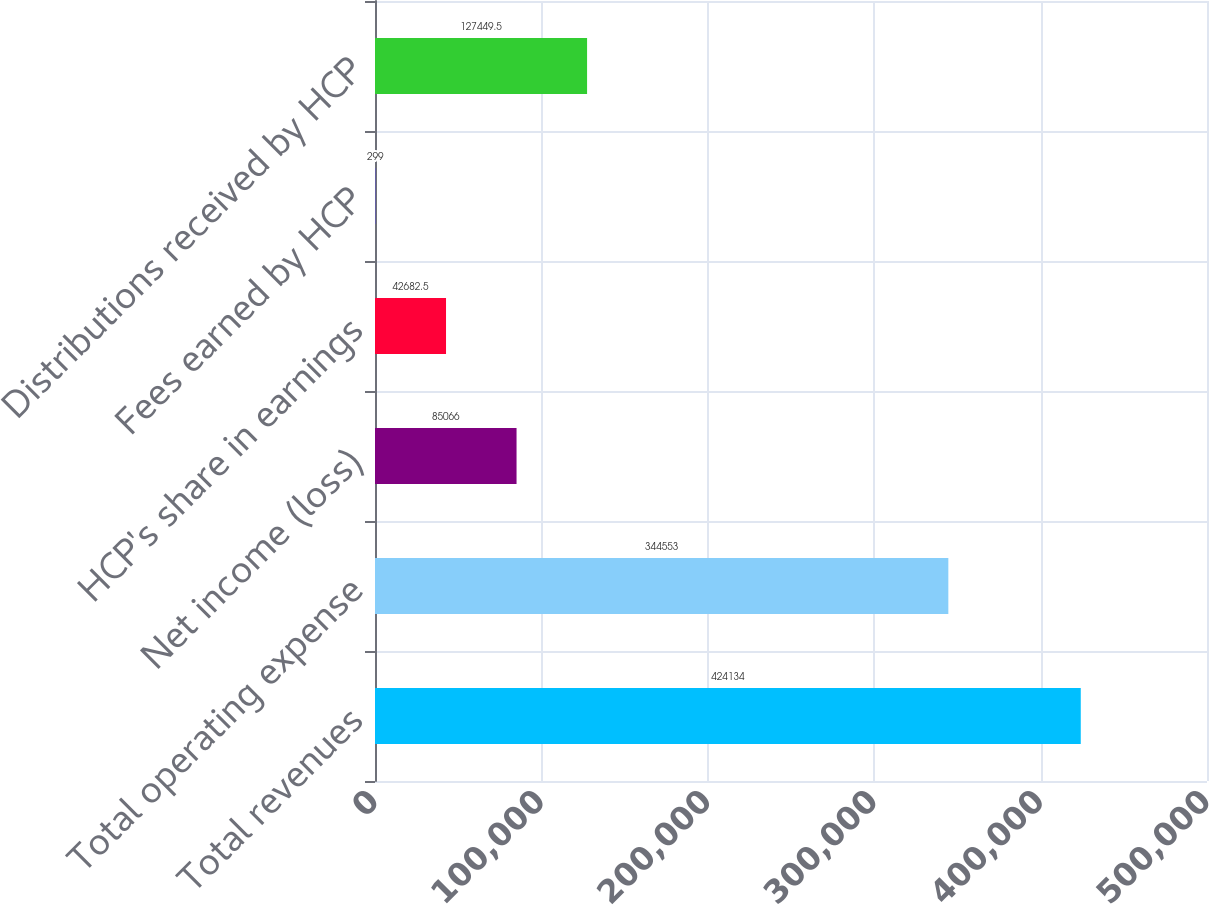Convert chart to OTSL. <chart><loc_0><loc_0><loc_500><loc_500><bar_chart><fcel>Total revenues<fcel>Total operating expense<fcel>Net income (loss)<fcel>HCP's share in earnings<fcel>Fees earned by HCP<fcel>Distributions received by HCP<nl><fcel>424134<fcel>344553<fcel>85066<fcel>42682.5<fcel>299<fcel>127450<nl></chart> 